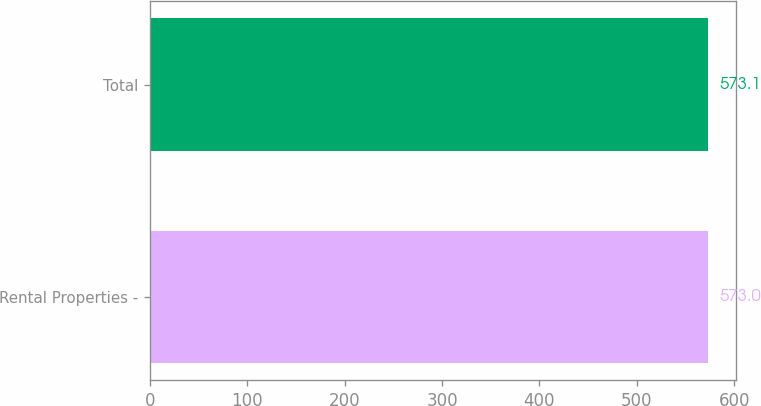Convert chart to OTSL. <chart><loc_0><loc_0><loc_500><loc_500><bar_chart><fcel>Rental Properties -<fcel>Total<nl><fcel>573<fcel>573.1<nl></chart> 